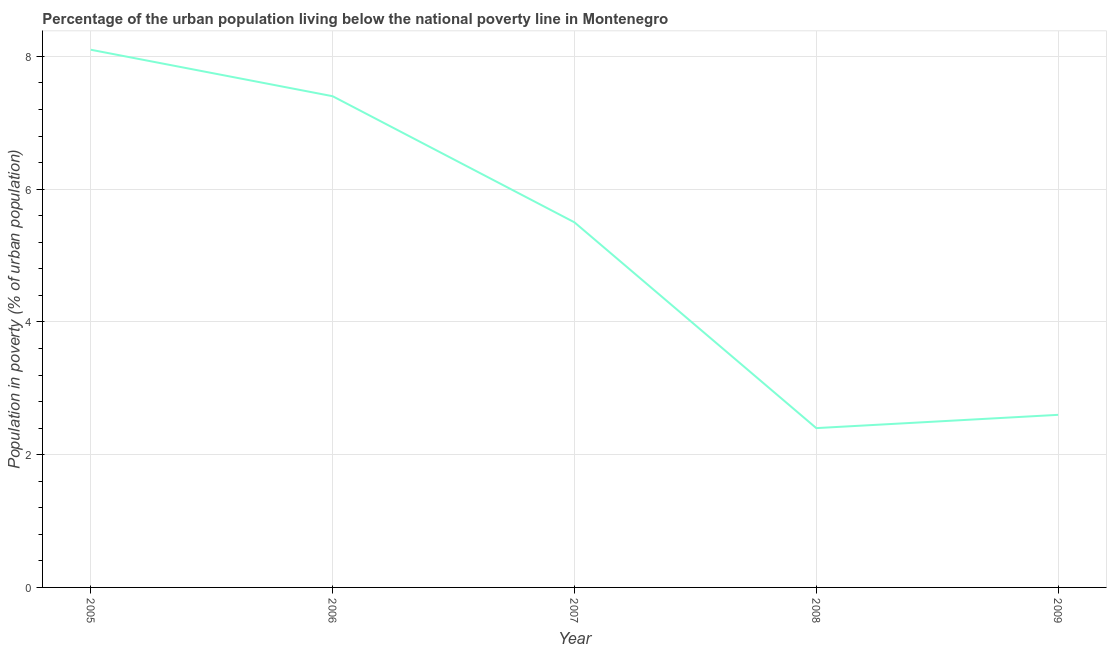In which year was the percentage of urban population living below poverty line maximum?
Ensure brevity in your answer.  2005. In which year was the percentage of urban population living below poverty line minimum?
Your response must be concise. 2008. What is the average percentage of urban population living below poverty line per year?
Your response must be concise. 5.2. What is the median percentage of urban population living below poverty line?
Your answer should be very brief. 5.5. In how many years, is the percentage of urban population living below poverty line greater than 2.4 %?
Ensure brevity in your answer.  4. Do a majority of the years between 2007 and 2008 (inclusive) have percentage of urban population living below poverty line greater than 0.4 %?
Your response must be concise. Yes. What is the ratio of the percentage of urban population living below poverty line in 2005 to that in 2008?
Give a very brief answer. 3.38. What is the difference between the highest and the second highest percentage of urban population living below poverty line?
Your answer should be very brief. 0.7. What is the difference between the highest and the lowest percentage of urban population living below poverty line?
Make the answer very short. 5.7. Does the percentage of urban population living below poverty line monotonically increase over the years?
Ensure brevity in your answer.  No. What is the difference between two consecutive major ticks on the Y-axis?
Make the answer very short. 2. Are the values on the major ticks of Y-axis written in scientific E-notation?
Your answer should be very brief. No. Does the graph contain grids?
Provide a succinct answer. Yes. What is the title of the graph?
Make the answer very short. Percentage of the urban population living below the national poverty line in Montenegro. What is the label or title of the Y-axis?
Provide a short and direct response. Population in poverty (% of urban population). What is the Population in poverty (% of urban population) in 2006?
Keep it short and to the point. 7.4. What is the Population in poverty (% of urban population) of 2009?
Give a very brief answer. 2.6. What is the difference between the Population in poverty (% of urban population) in 2005 and 2006?
Offer a terse response. 0.7. What is the difference between the Population in poverty (% of urban population) in 2005 and 2009?
Provide a short and direct response. 5.5. What is the difference between the Population in poverty (% of urban population) in 2006 and 2007?
Provide a short and direct response. 1.9. What is the difference between the Population in poverty (% of urban population) in 2006 and 2009?
Provide a short and direct response. 4.8. What is the difference between the Population in poverty (% of urban population) in 2007 and 2009?
Your answer should be compact. 2.9. What is the difference between the Population in poverty (% of urban population) in 2008 and 2009?
Provide a succinct answer. -0.2. What is the ratio of the Population in poverty (% of urban population) in 2005 to that in 2006?
Your answer should be compact. 1.09. What is the ratio of the Population in poverty (% of urban population) in 2005 to that in 2007?
Your answer should be compact. 1.47. What is the ratio of the Population in poverty (% of urban population) in 2005 to that in 2008?
Give a very brief answer. 3.38. What is the ratio of the Population in poverty (% of urban population) in 2005 to that in 2009?
Offer a very short reply. 3.12. What is the ratio of the Population in poverty (% of urban population) in 2006 to that in 2007?
Ensure brevity in your answer.  1.34. What is the ratio of the Population in poverty (% of urban population) in 2006 to that in 2008?
Provide a succinct answer. 3.08. What is the ratio of the Population in poverty (% of urban population) in 2006 to that in 2009?
Make the answer very short. 2.85. What is the ratio of the Population in poverty (% of urban population) in 2007 to that in 2008?
Your response must be concise. 2.29. What is the ratio of the Population in poverty (% of urban population) in 2007 to that in 2009?
Provide a short and direct response. 2.12. What is the ratio of the Population in poverty (% of urban population) in 2008 to that in 2009?
Offer a terse response. 0.92. 